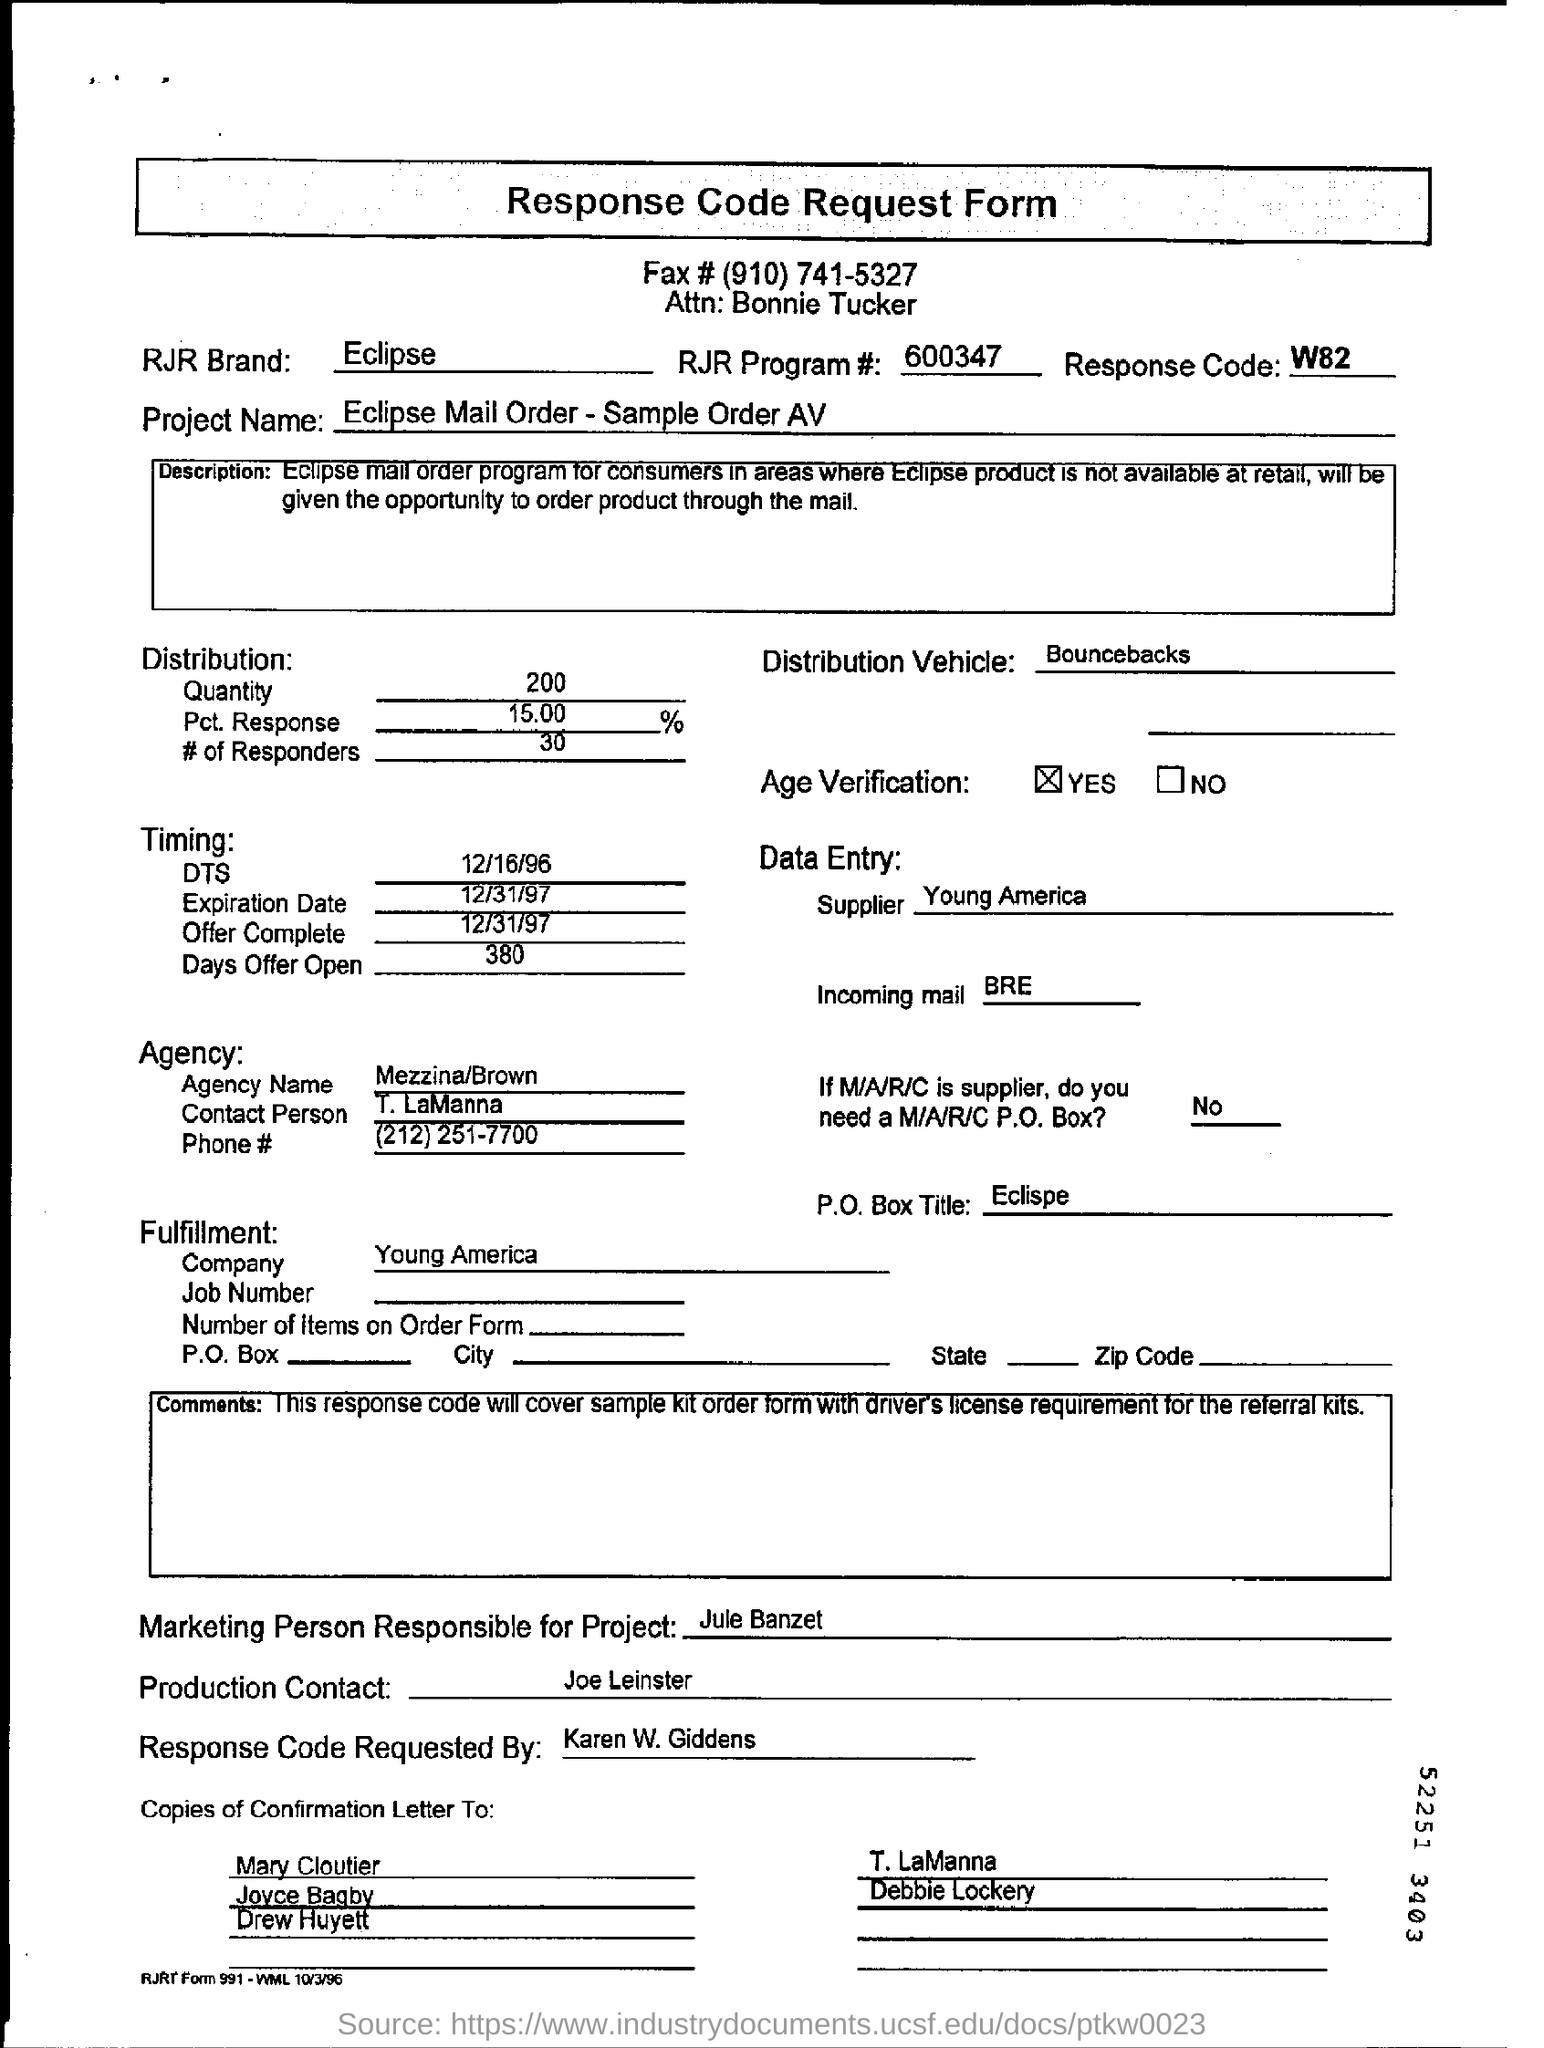Is the Age Verification completed?
Provide a succinct answer. Yes. 